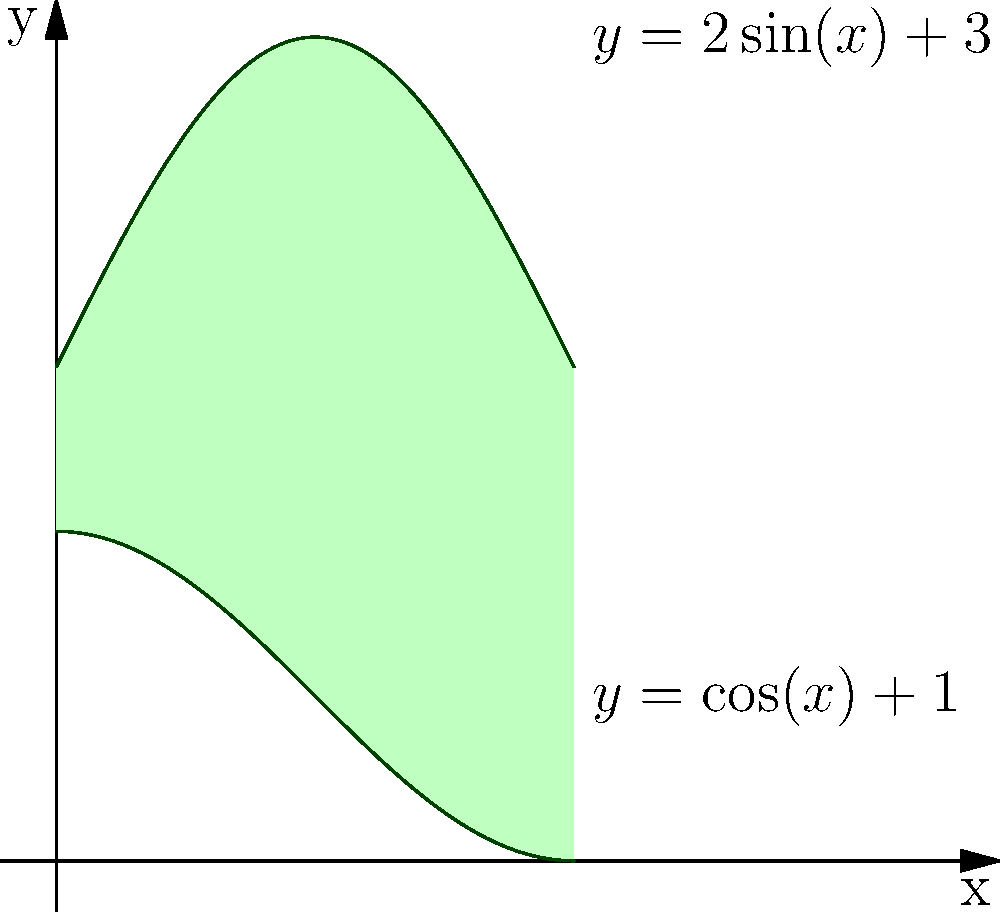As part of your trail maintenance duties, you've discovered an irregularly shaped clearing in the woodlands. The clearing's boundary can be modeled by two functions: $y = 2\sin(x) + 3$ (upper curve) and $y = \cos(x) + 1$ (lower curve), where $x$ is measured in radians from 0 to $\pi$. Calculate the area of this clearing using integration techniques. To find the area of the irregularly shaped clearing, we need to:

1) Identify the area to be calculated:
   It's the region bounded by $y = 2\sin(x) + 3$ above and $y = \cos(x) + 1$ below, from $x = 0$ to $x = \pi$.

2) Set up the integral:
   Area = $\int_{0}^{\pi} [(2\sin(x) + 3) - (\cos(x) + 1)] dx$

3) Simplify the integrand:
   Area = $\int_{0}^{\pi} [2\sin(x) - \cos(x) + 2] dx$

4) Integrate each term:
   Area = $[-2\cos(x) - \sin(x) + 2x]_{0}^{\pi}$

5) Evaluate the integral:
   Area = $[(-2\cos(\pi) - \sin(\pi) + 2\pi) - (-2\cos(0) - \sin(0) + 2(0))]$
        = $[(2 - 0 + 2\pi) - (-2 - 0 + 0)]$
        = $(2 + 2\pi) - (-2)$
        = $2\pi + 4$

6) The area is in square units (e.g., square meters or square feet, depending on the scale used).
Answer: $2\pi + 4$ square units 